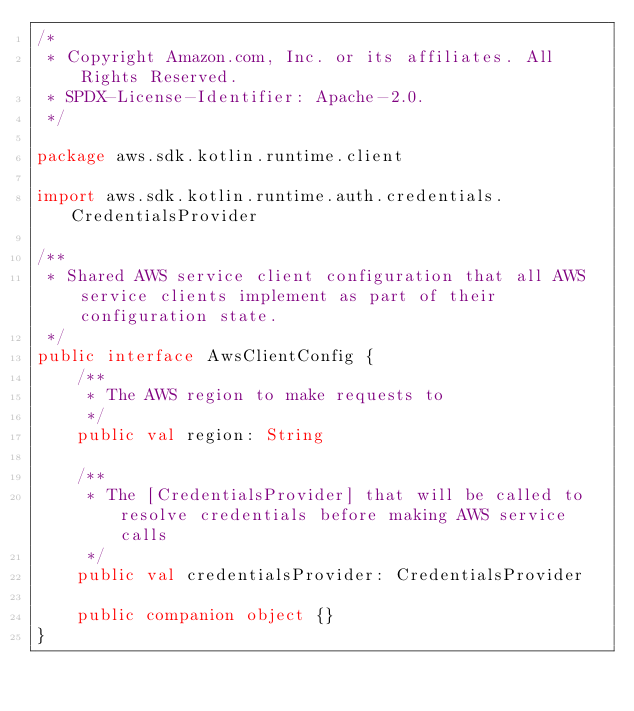<code> <loc_0><loc_0><loc_500><loc_500><_Kotlin_>/*
 * Copyright Amazon.com, Inc. or its affiliates. All Rights Reserved.
 * SPDX-License-Identifier: Apache-2.0.
 */

package aws.sdk.kotlin.runtime.client

import aws.sdk.kotlin.runtime.auth.credentials.CredentialsProvider

/**
 * Shared AWS service client configuration that all AWS service clients implement as part of their configuration state.
 */
public interface AwsClientConfig {
    /**
     * The AWS region to make requests to
     */
    public val region: String

    /**
     * The [CredentialsProvider] that will be called to resolve credentials before making AWS service calls
     */
    public val credentialsProvider: CredentialsProvider

    public companion object {}
}
</code> 